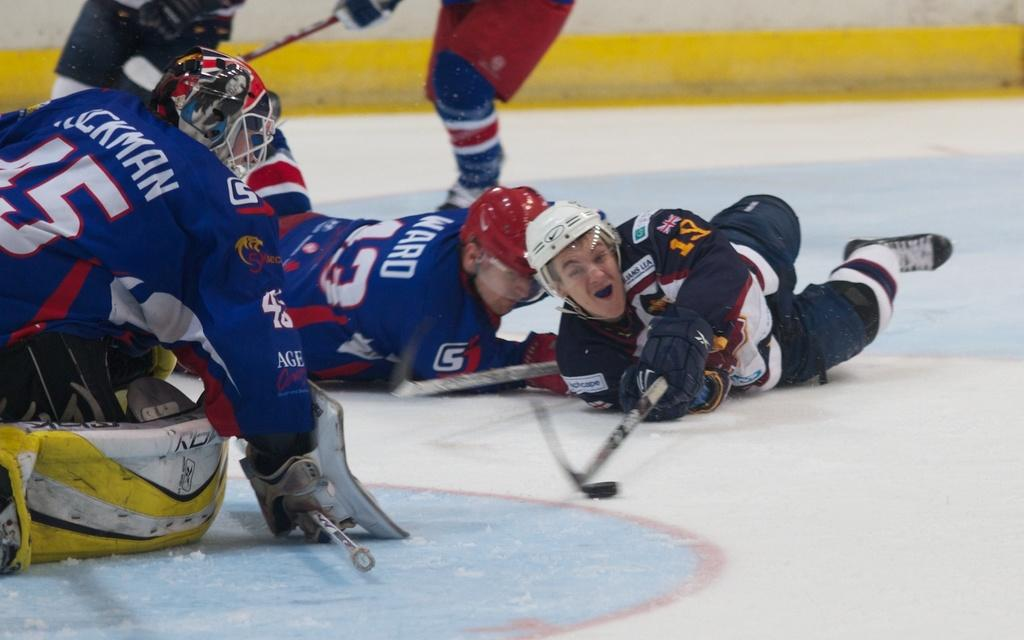How many people are in the image? There are people in the image, but the exact number is not specified. What are the people wearing in the image? The people are wearing the same costume in the image. What position are the people in? The people are lying on the ground in the image. What objects are the people holding in the image? The people are holding hockey bats in the image. What type of stick is used to stir the plate in the image? There is no stick or plate present in the image. How many bases are visible in the image? There is no mention of bases in the image. 